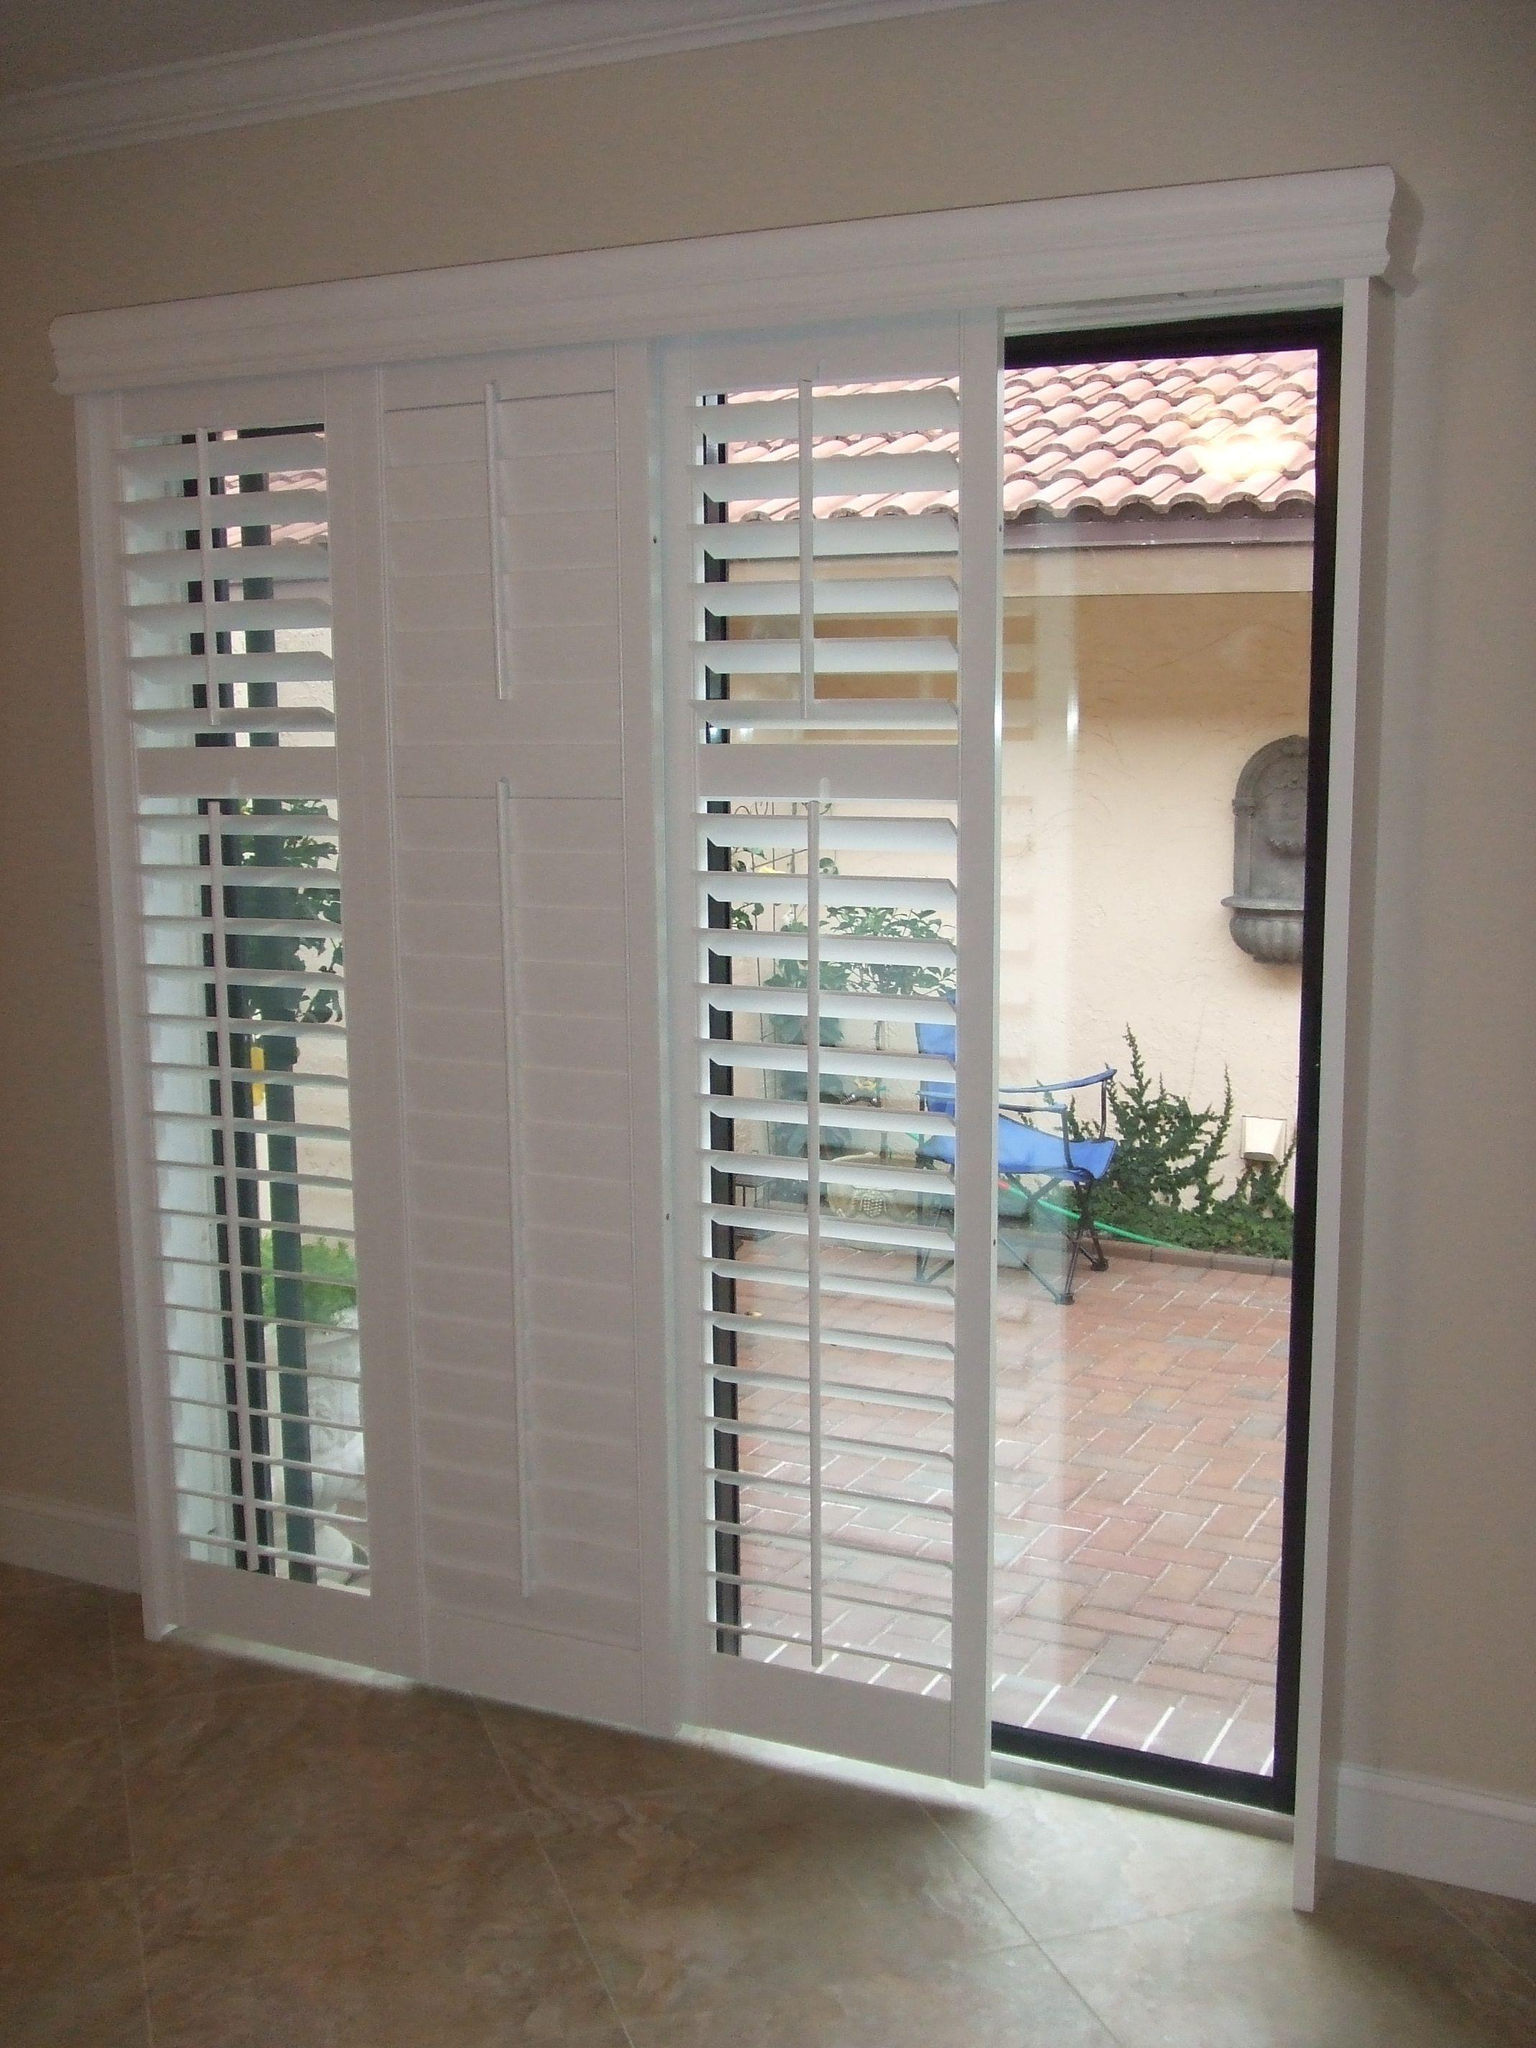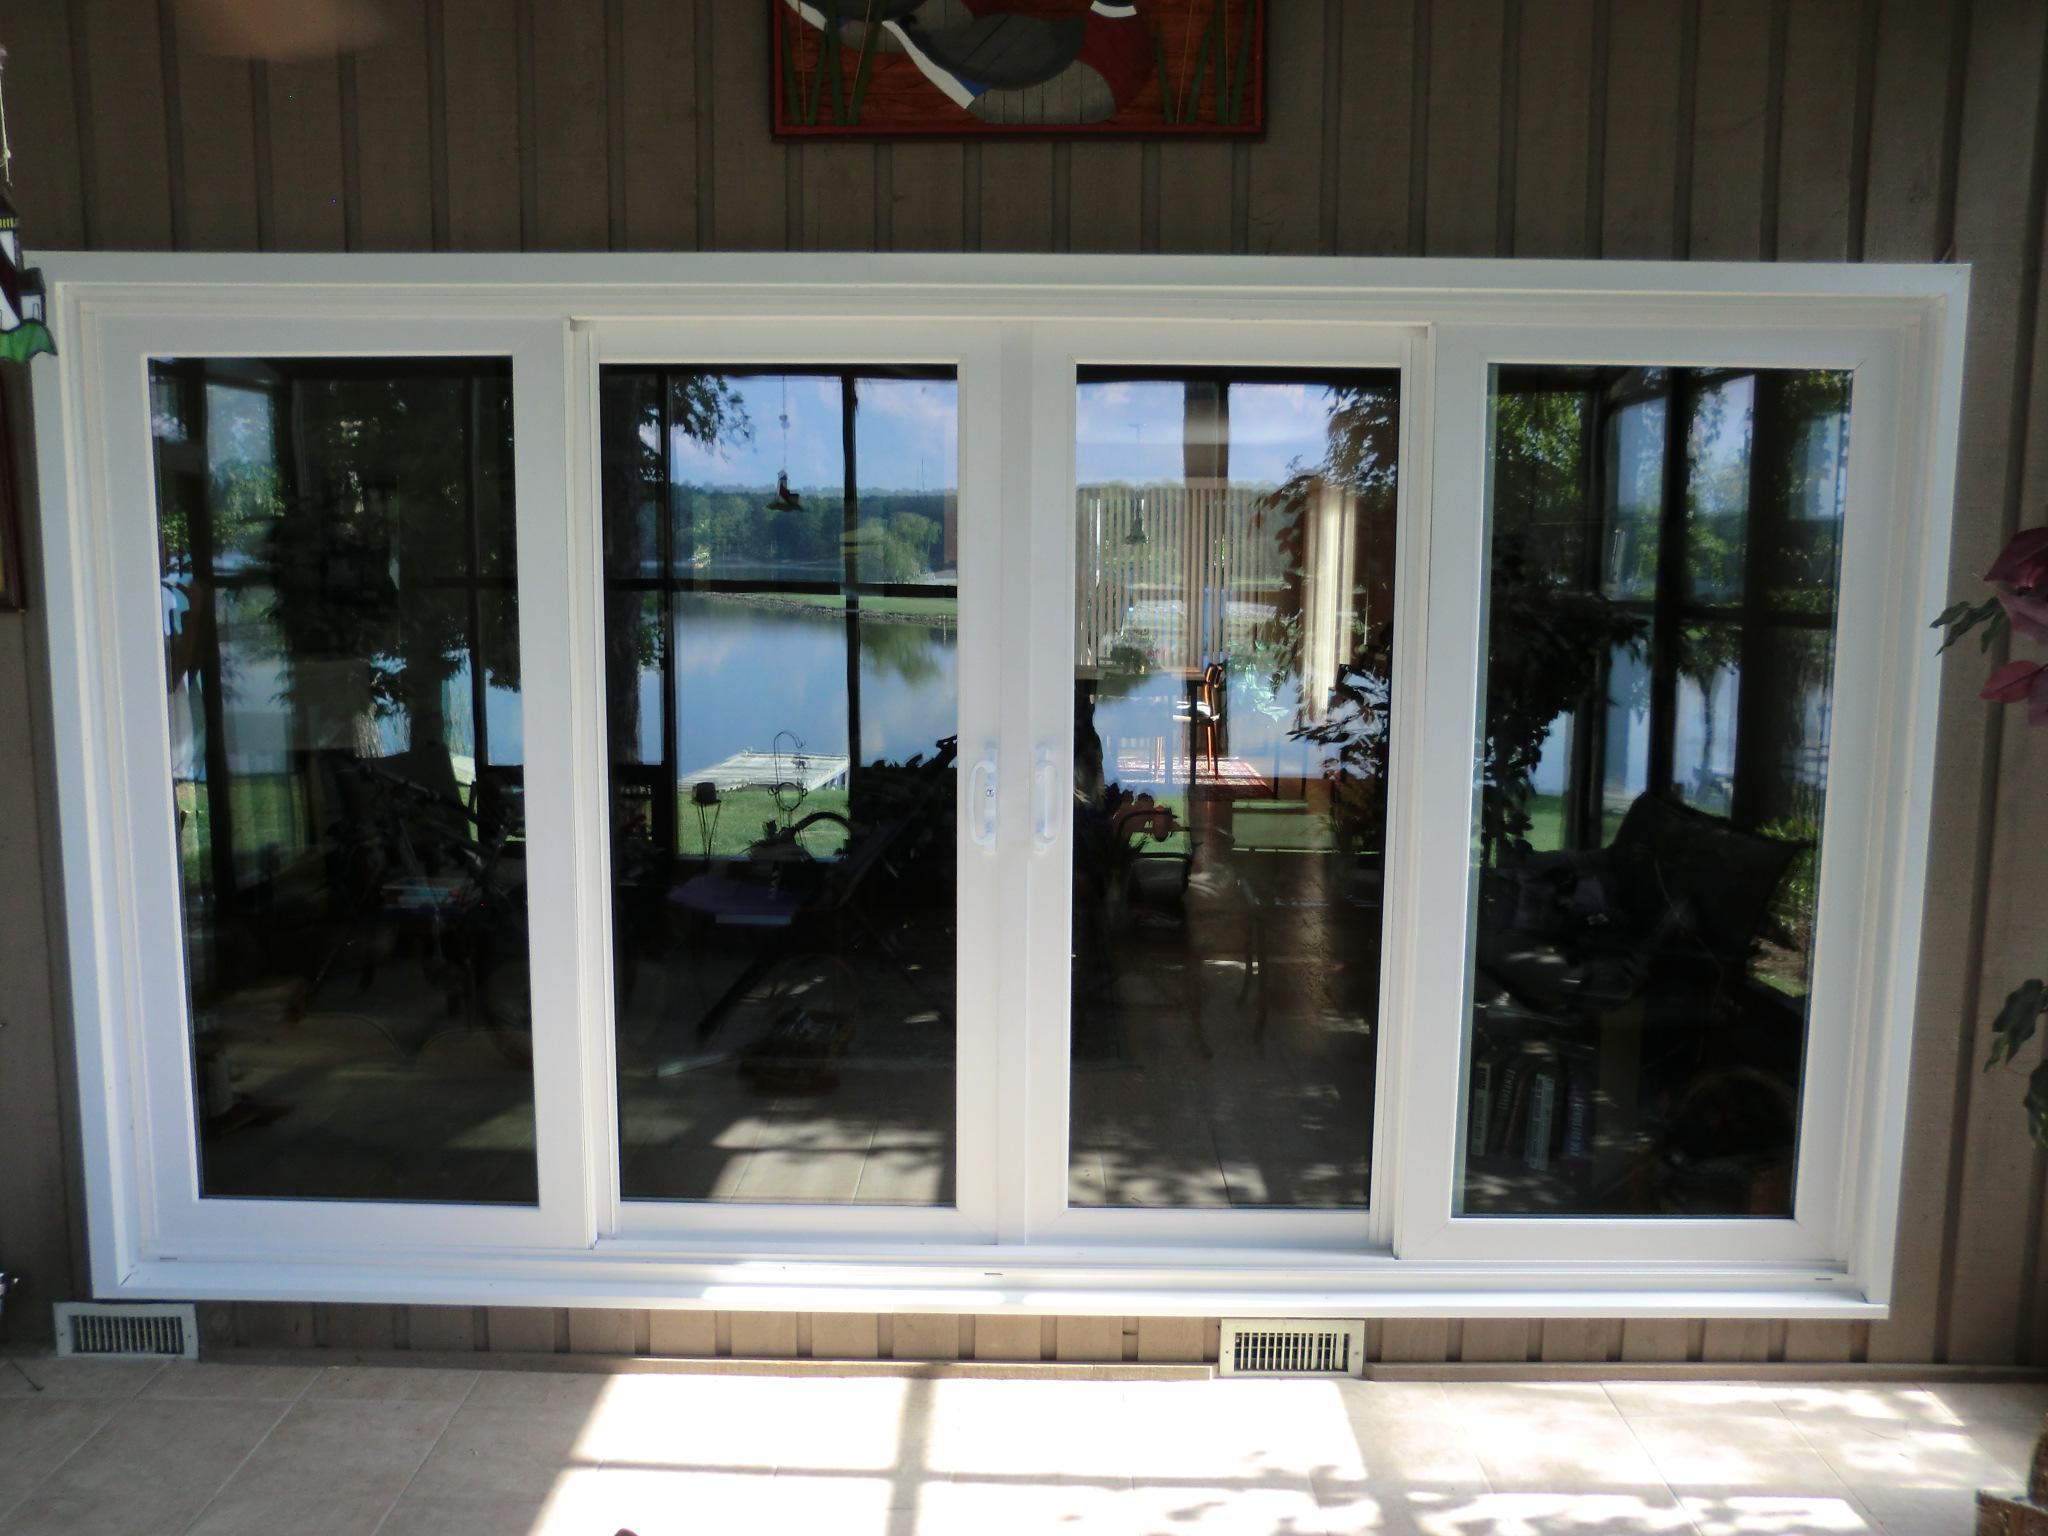The first image is the image on the left, the second image is the image on the right. For the images shown, is this caption "One of the images has horizontal blinds on the glass doors." true? Answer yes or no. Yes. The first image is the image on the left, the second image is the image on the right. Analyze the images presented: Is the assertion "An image shows a rectangle with four white-framed door sections surrounded by grayish wall." valid? Answer yes or no. Yes. 